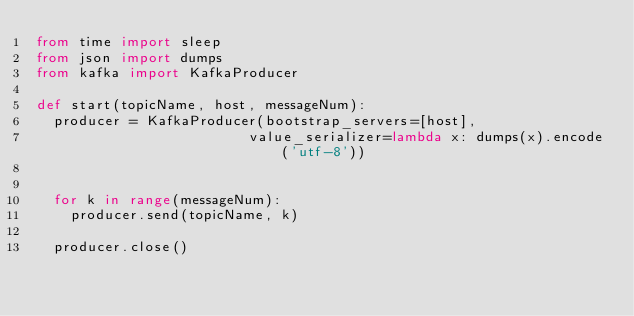Convert code to text. <code><loc_0><loc_0><loc_500><loc_500><_Python_>from time import sleep
from json import dumps
from kafka import KafkaProducer

def start(topicName, host, messageNum):
	producer = KafkaProducer(bootstrap_servers=[host],
                         value_serializer=lambda x: dumps(x).encode('utf-8'))
                         
                         
	for k in range(messageNum):
		producer.send(topicName, k)
    
	producer.close()
	

</code> 